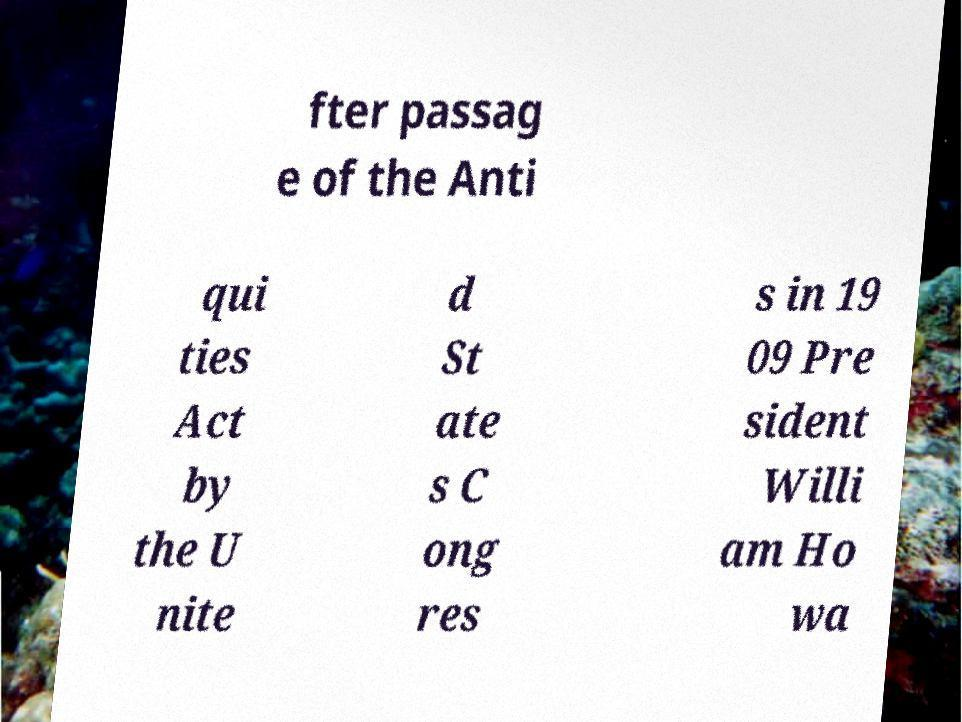For documentation purposes, I need the text within this image transcribed. Could you provide that? fter passag e of the Anti qui ties Act by the U nite d St ate s C ong res s in 19 09 Pre sident Willi am Ho wa 